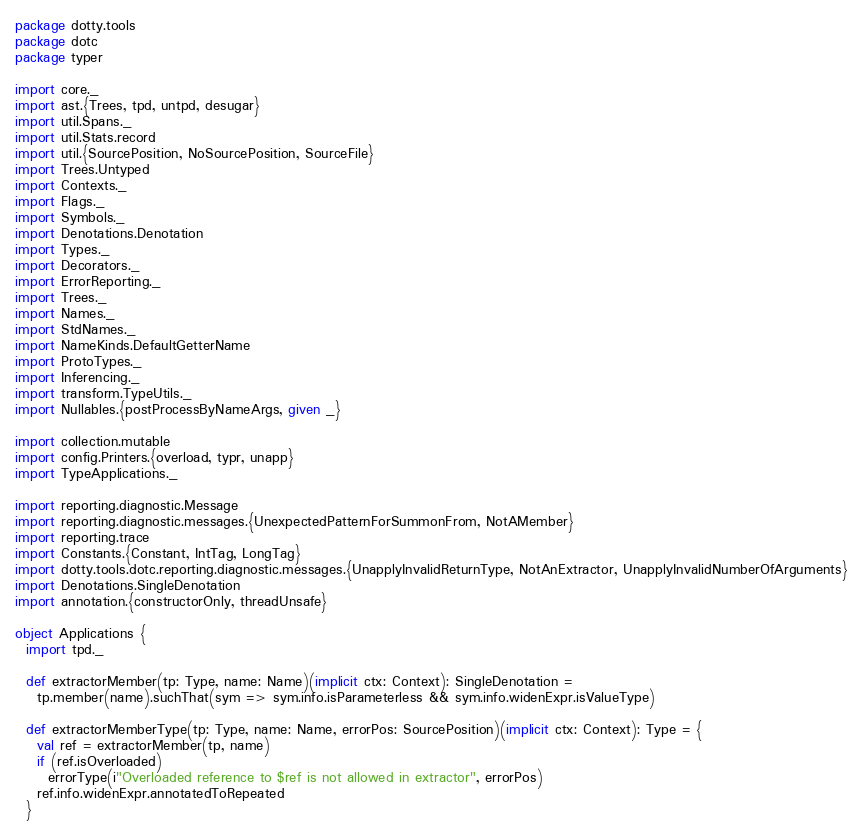Convert code to text. <code><loc_0><loc_0><loc_500><loc_500><_Scala_>package dotty.tools
package dotc
package typer

import core._
import ast.{Trees, tpd, untpd, desugar}
import util.Spans._
import util.Stats.record
import util.{SourcePosition, NoSourcePosition, SourceFile}
import Trees.Untyped
import Contexts._
import Flags._
import Symbols._
import Denotations.Denotation
import Types._
import Decorators._
import ErrorReporting._
import Trees._
import Names._
import StdNames._
import NameKinds.DefaultGetterName
import ProtoTypes._
import Inferencing._
import transform.TypeUtils._
import Nullables.{postProcessByNameArgs, given _}

import collection.mutable
import config.Printers.{overload, typr, unapp}
import TypeApplications._

import reporting.diagnostic.Message
import reporting.diagnostic.messages.{UnexpectedPatternForSummonFrom, NotAMember}
import reporting.trace
import Constants.{Constant, IntTag, LongTag}
import dotty.tools.dotc.reporting.diagnostic.messages.{UnapplyInvalidReturnType, NotAnExtractor, UnapplyInvalidNumberOfArguments}
import Denotations.SingleDenotation
import annotation.{constructorOnly, threadUnsafe}

object Applications {
  import tpd._

  def extractorMember(tp: Type, name: Name)(implicit ctx: Context): SingleDenotation =
    tp.member(name).suchThat(sym => sym.info.isParameterless && sym.info.widenExpr.isValueType)

  def extractorMemberType(tp: Type, name: Name, errorPos: SourcePosition)(implicit ctx: Context): Type = {
    val ref = extractorMember(tp, name)
    if (ref.isOverloaded)
      errorType(i"Overloaded reference to $ref is not allowed in extractor", errorPos)
    ref.info.widenExpr.annotatedToRepeated
  }
</code> 